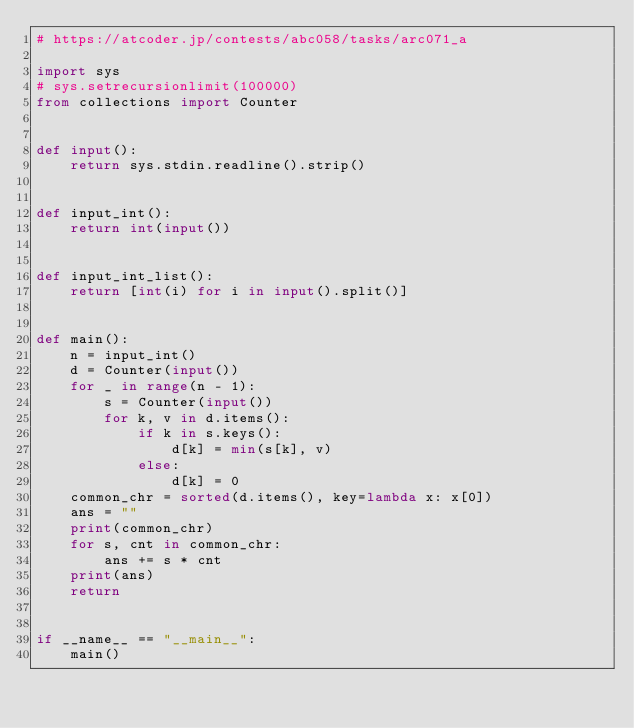<code> <loc_0><loc_0><loc_500><loc_500><_Python_># https://atcoder.jp/contests/abc058/tasks/arc071_a

import sys
# sys.setrecursionlimit(100000)
from collections import Counter


def input():
    return sys.stdin.readline().strip()


def input_int():
    return int(input())


def input_int_list():
    return [int(i) for i in input().split()]


def main():
    n = input_int()
    d = Counter(input())
    for _ in range(n - 1):
        s = Counter(input())
        for k, v in d.items():
            if k in s.keys():
                d[k] = min(s[k], v)
            else:
                d[k] = 0
    common_chr = sorted(d.items(), key=lambda x: x[0])
    ans = ""
    print(common_chr)
    for s, cnt in common_chr:
        ans += s * cnt
    print(ans)
    return


if __name__ == "__main__":
    main()
</code> 